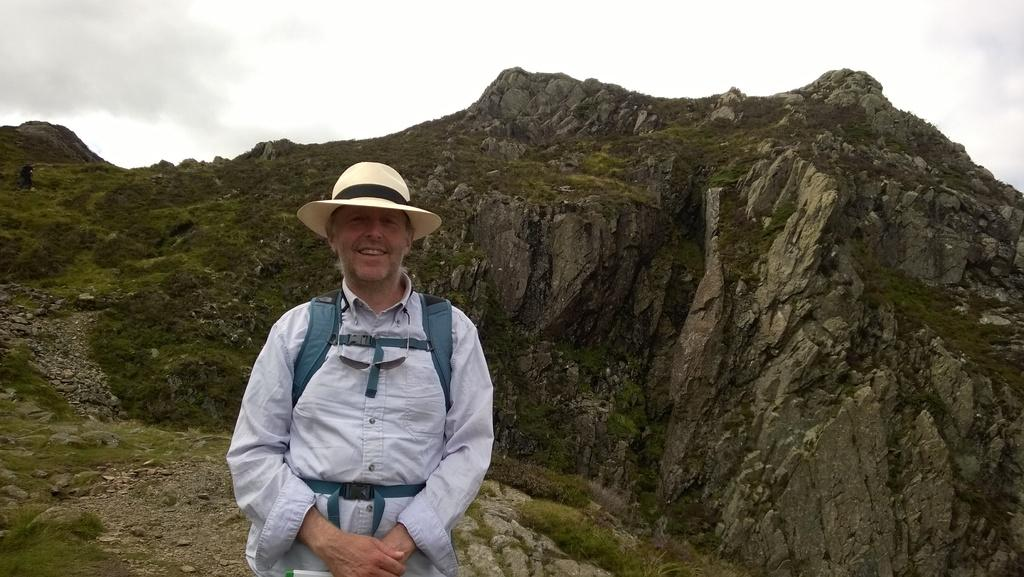What is the main subject in the foreground of the image? There is a man standing in the foreground of the image. What is the man wearing on his body? The man is wearing a bag and a hat. What can be seen in the background of the image? There is a cliff and the sky visible in the background of the image. What type of substance is the man using to support his feet on the cliff? The image does not show the man on the cliff or any substance supporting his feet. 